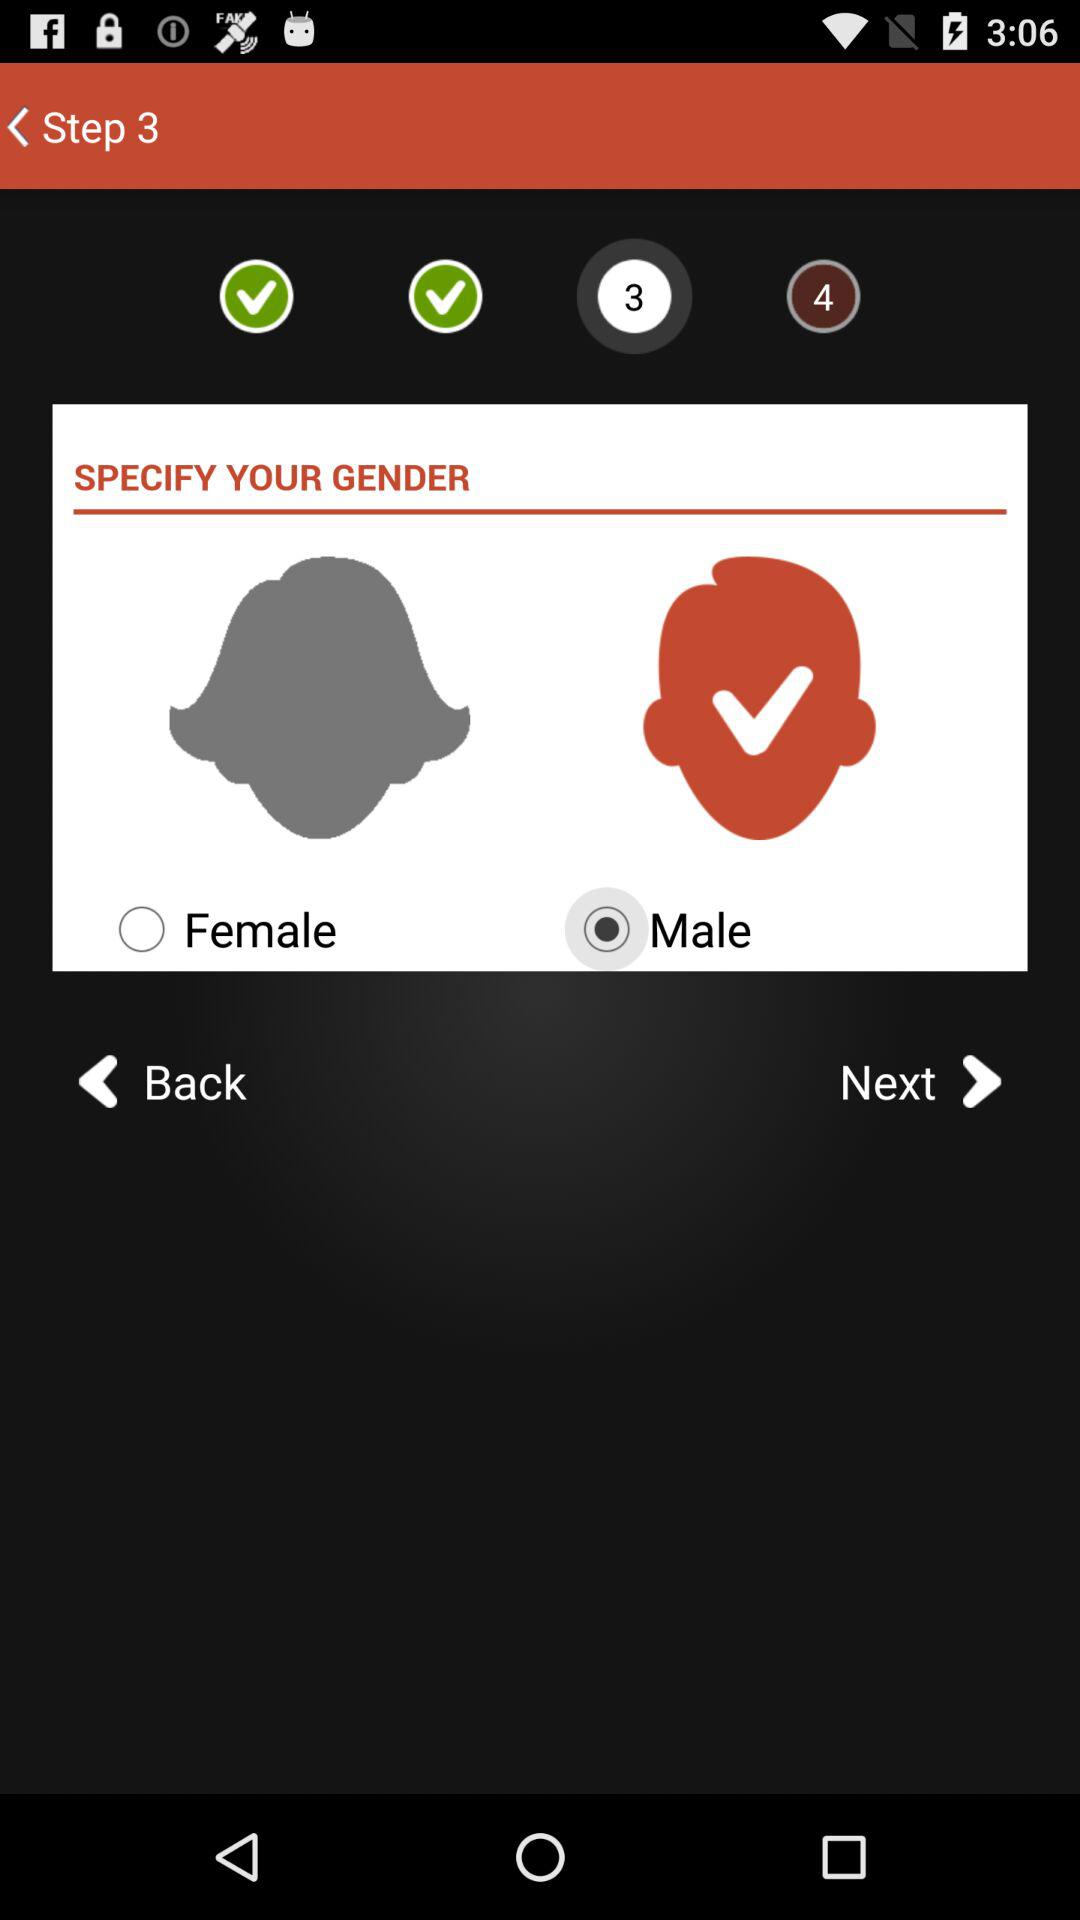How many steps in total are there? There are 4 steps in total. 